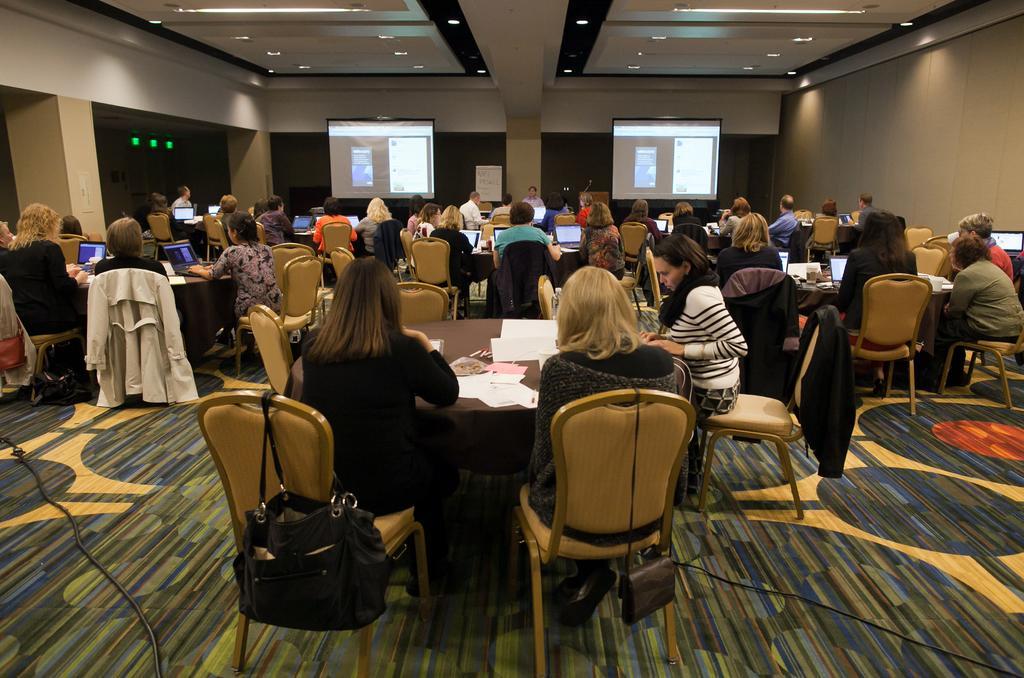Can you describe this image briefly? Most of the persons are sitting on chairs. We can see number of tables, on this tables there are laptops, papers and things. Far there are 2 screens. On top there are lights. On this chair there is a bag. On this chair there is a jacket. 